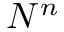<formula> <loc_0><loc_0><loc_500><loc_500>N ^ { n }</formula> 